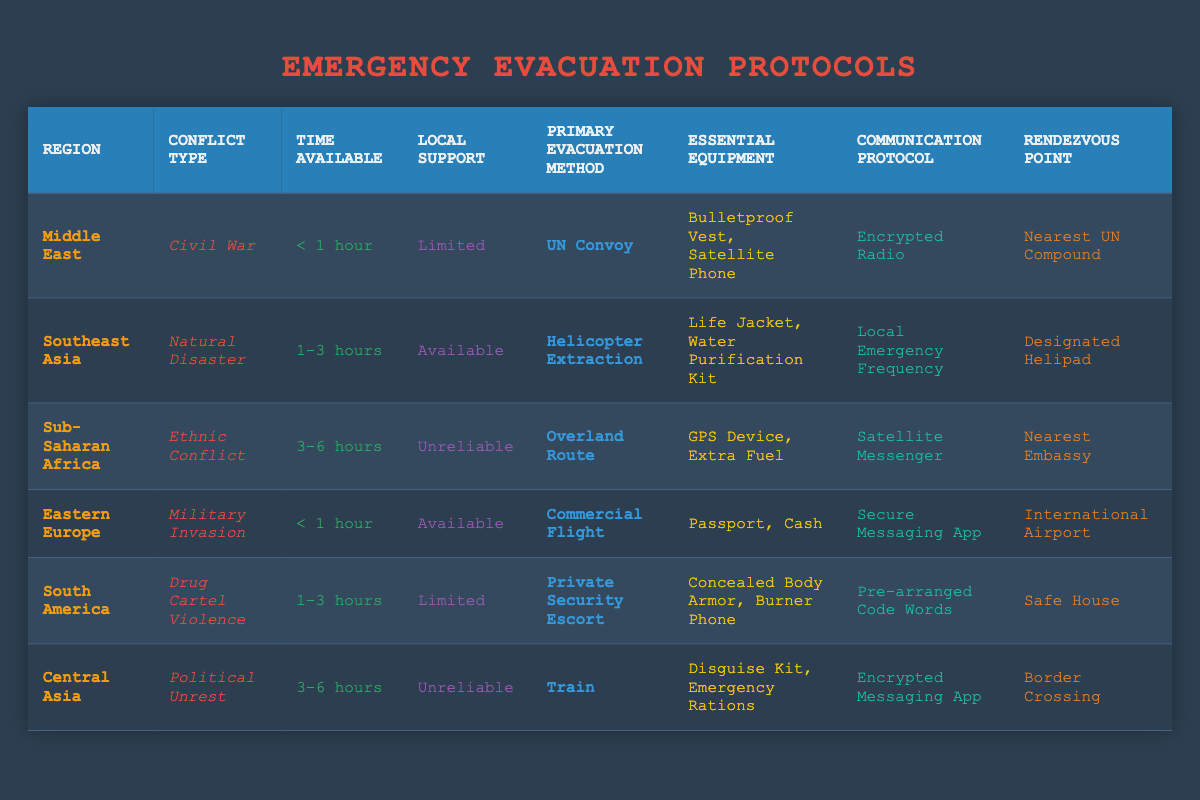What is the primary evacuation method for the Middle East? The table indicates that the primary evacuation method for the Middle East is "UN Convoy." This can be directly retrieved from the row corresponding to the Middle East.
Answer: UN Convoy Which region has the longest time available for evacuation? By comparing the "Time Available" column, Sub-Saharan Africa has the longest time available at "3-6 hours." This is the maximum range listed in that column.
Answer: Sub-Saharan Africa Is local support available for the Eastern Europe conflict? Referring to the entry for Eastern Europe, it states that local support is "Available," confirming that local assistance can be expected during the conflict.
Answer: Yes What essential equipment is recommended for a natural disaster in Southeast Asia? The table states that for a natural disaster in Southeast Asia, the essential equipment includes a "Life Jacket" and a "Water Purification Kit." This is specified in the row for this region and conflict type.
Answer: Life Jacket, Water Purification Kit What are the communication protocols for regions with limited local support? The regions with limited local support are the Middle East and South America. Their respective communication protocols are "Encrypted Radio" and "Pre-arranged Code Words." The answer involves checking both entries for these regions.
Answer: Encrypted Radio, Pre-arranged Code Words How many regions have an available local support state and a time available less than 1 hour? There are two regions listed: the Eastern Europe and Middle East entries both have "Available" local support and a "Time Available" of less than 1 hour. Therefore, the count for this condition is 2.
Answer: 2 Which region requires a rendezvous point at a border crossing? The table reveals that the rendezvous point for Central Asia is "Border Crossing," as stated in the row for this region and the associated conflict type.
Answer: Central Asia What is the average time available for evacuation across all regions? The times available listed are "< 1 hour," "1-3 hours," "3-6 hours." We convert them for calculation: 0.5 hours, 2 hours, and 4.5 hours respectively (assuming midpoint for ranges). The average calculation is (0.5 + 2 + 4.5 + 0.5 + 2 + 4.5)/6 = 2.5 hours.
Answer: 2.5 hours What are the essential pieces of equipment for the evacuation method that involves helicopter extraction? Referring to Southeast Asia's row, the essential equipment for helicopter extraction includes "Life Jacket" and "Water Purification Kit." This information is directly available in the table.
Answer: Life Jacket, Water Purification Kit 